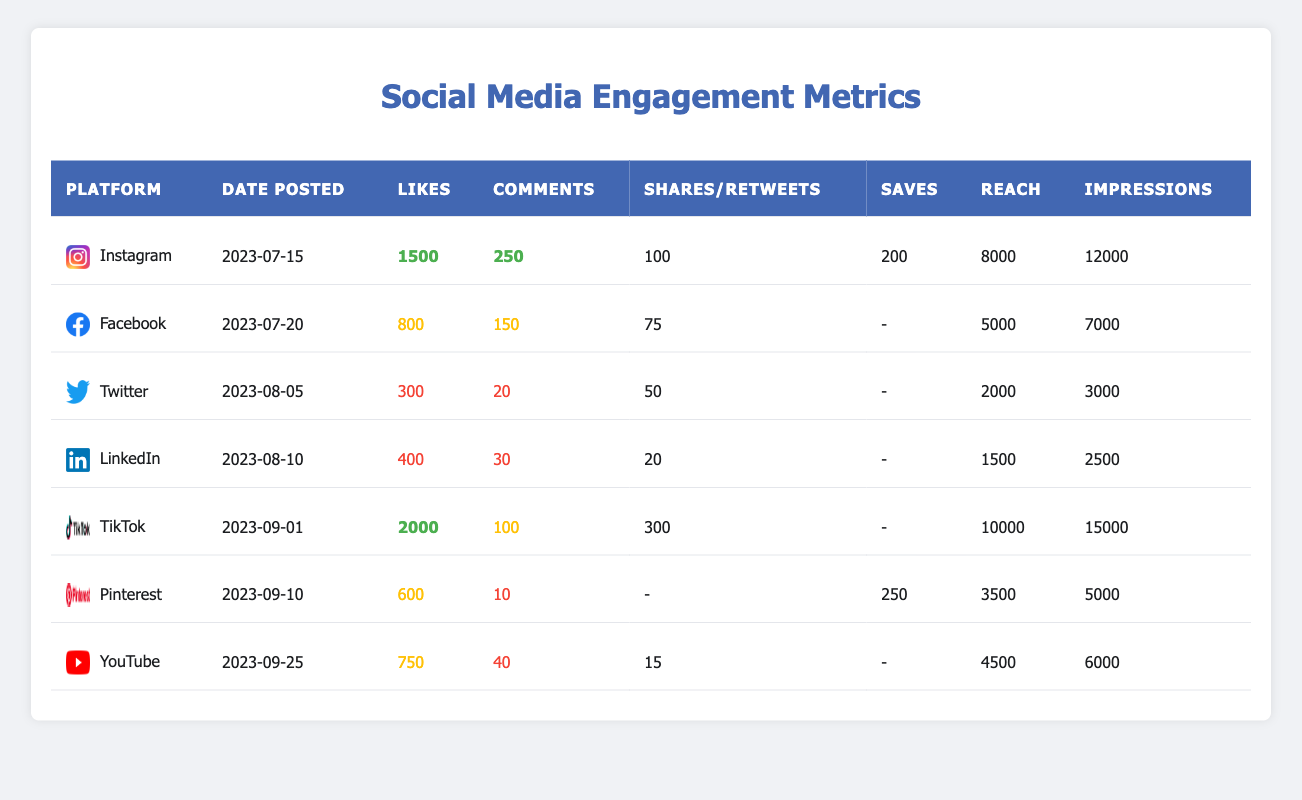What is the post with the highest number of likes? The table shows each post's likes, and by comparing the values, Post ID 005 on TikTok has the highest likes at 2000.
Answer: 005 Which platform had the lowest reach? By examining the reach column, Post ID 004 on LinkedIn has the lowest reach value of 1500.
Answer: LinkedIn What is the total number of comments across all posts? Summing all the comments from each post: (250 + 150 + 20 + 30 + 100 + 10 + 40) = 600. Therefore, the total number of comments is 600.
Answer: 600 True or False: The total number of saves for the Facebook post is greater than 100. The Facebook post does not have any save data listed (it's marked as "-"), so it's false to say it's greater than 100.
Answer: False What is the average number of likes per post? There are 7 posts, and the total likes sum is (1500 + 800 + 300 + 400 + 2000 + 600 + 750) = 5250. The average likes per post is 5250 / 7 ≈ 750.
Answer: 750 Which post had the highest total engagement (likes + comments + shares/saves)? Calculating the total engagement for each post: Post 001 (1500 + 250 + 100 + 200 = 2050), Post 002 (800 + 150 + 75 = 1025), Post 003 (300 + 20 + 50 = 370), Post 004 (400 + 30 + 20 = 450), Post 005 (2000 + 100 + 300 = 2400), Post 006 (600 + 10 + 250 = 860), Post 007 (750 + 40 + 15 = 805). Post 005 has the highest engagement at 2400.
Answer: 005 How many shares were recorded for the Instagram post? The shares for the Instagram post (Post ID 001) are directly listed as 100 in the table.
Answer: 100 What is the difference in impressions between the TikTok post and the LinkedIn post? The impressions for TikTok (Post ID 005) is 15000 and for LinkedIn (Post ID 004) it's 2500. The difference is 15000 - 2500 = 12500.
Answer: 12500 